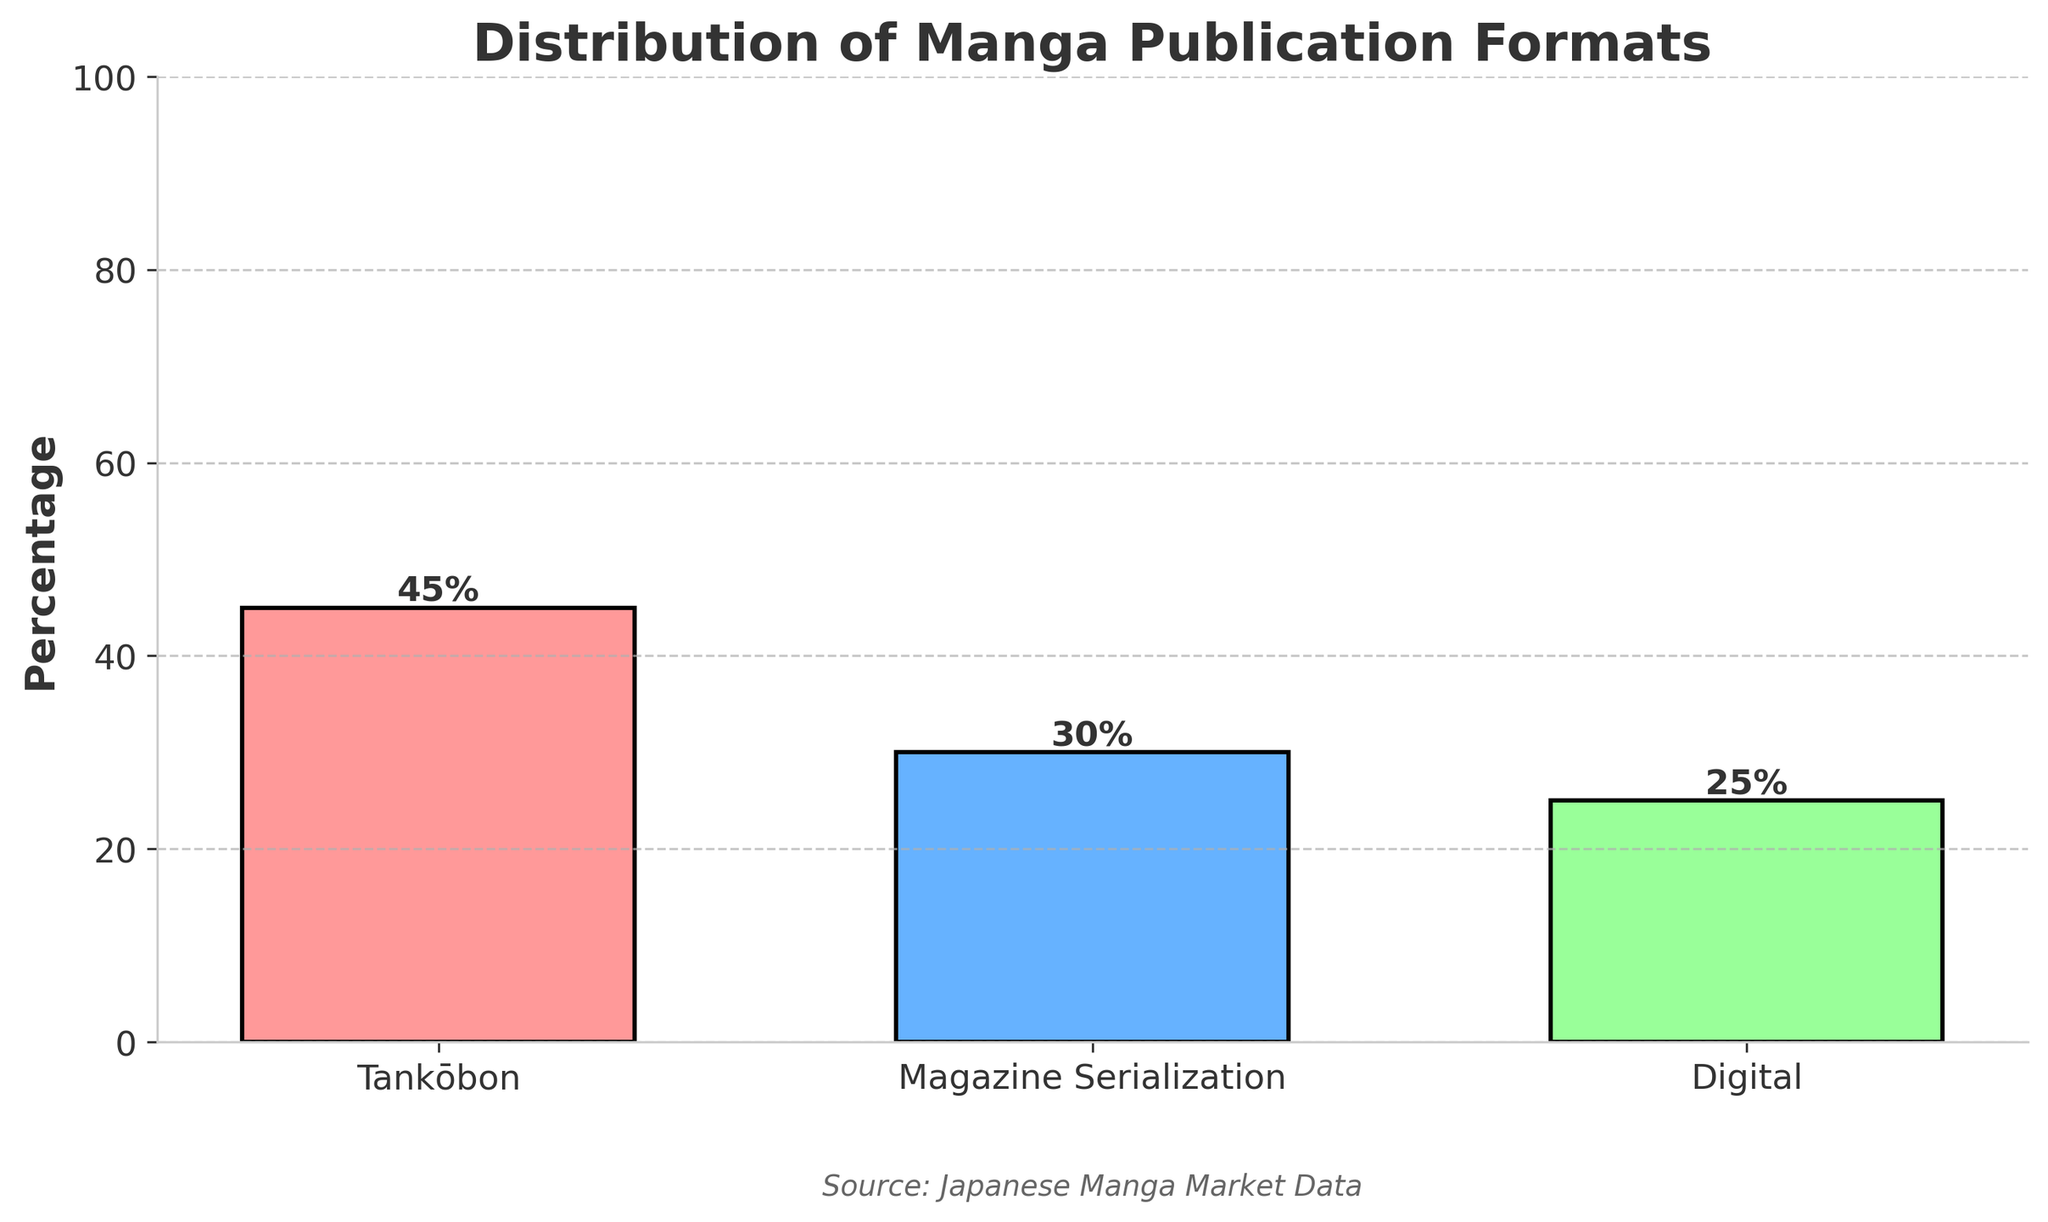Which manga publication format has the highest percentage? By looking at the figure, the tallest bar represents the format with the highest percentage, which is Tankōbon with 45%.
Answer: Tankōbon What is the combined percentage of Magazine Serialization and Digital formats? First, check the percentage value for Magazine Serialization (30%) and Digital (25%). Add these values together: 30 + 25 = 55%.
Answer: 55% By how much percentage is Tankōbon more popular than Digital format? The percentage of Tankōbon is 45% and Digital is 25%. Subtract the percentage of Digital from Tankōbon: 45 - 25 = 20%.
Answer: 20% Which format has the smallest percentage share? The shortest bar indicates the format with the smallest percentage share, which is Digital with 25%.
Answer: Digital How many types of publication formats are shown in the figure? Count the number of distinct bars, each representing a unique publication format. There are three bars: Tankōbon, Magazine Serialization, and Digital.
Answer: 3 What fraction of the total market does Digital format represent when combined with Tankōbon? Add the percentages of Digital (25%) and Tankōbon (45%): 25 + 45 = 70%.
Answer: 70% Which format is represented by the blue bar? Identify the colors associated with each bar in the figure. The blue bar represents Magazine Serialization, which has a 30% share.
Answer: Magazine Serialization Is the percentage of Magazine Serialization greater or less than that of Tankōbon? Compare the percentages of Magazine Serialization (30%) and Tankōbon (45%). Since 30 is less than 45, Magazine Serialization is less.
Answer: Less What is the percentage difference between the most and least popular formats? The most popular format is Tankōbon (45%) and the least is Digital (25%). Subtract the least from the most: 45 - 25 = 20%.
Answer: 20% What color represents the Tankōbon format? Look for the color of the bar labeled "Tankōbon". It is represented by the red bar.
Answer: Red 